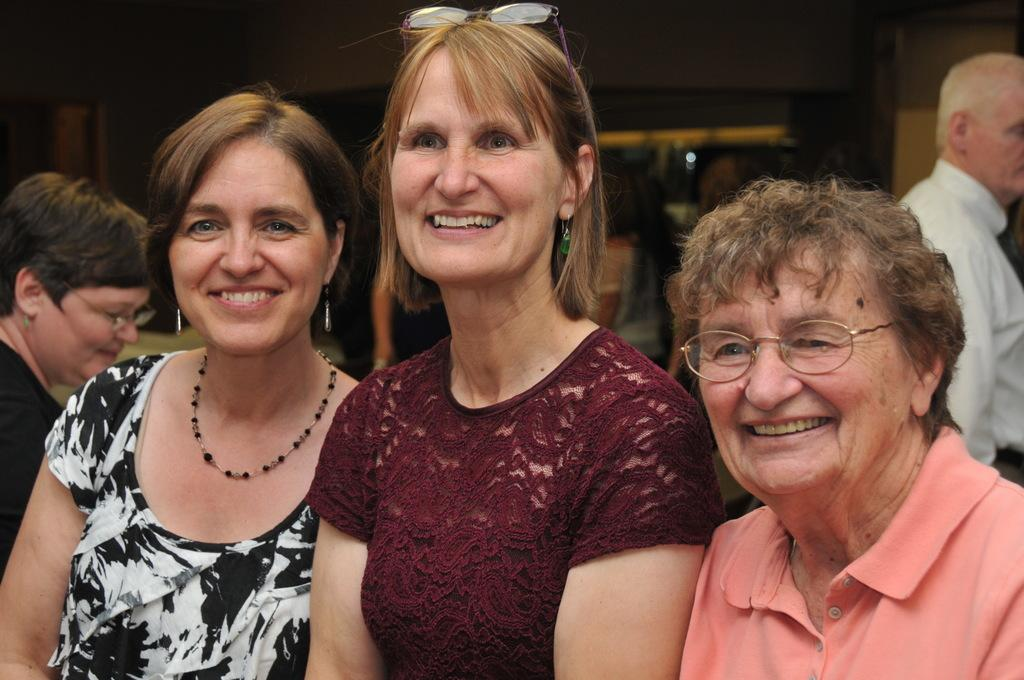What type of people can be seen in the image? There are women in the image. Can you describe the background of the image? There are persons in the background of the image, as well as a door and a wall. What type of needle is being used by the women in the image? There is no needle present in the image; it only features women and elements in the background. What type of apparatus is being used by the women in the image? There is no apparatus present in the image; it only features women and elements in the background. 